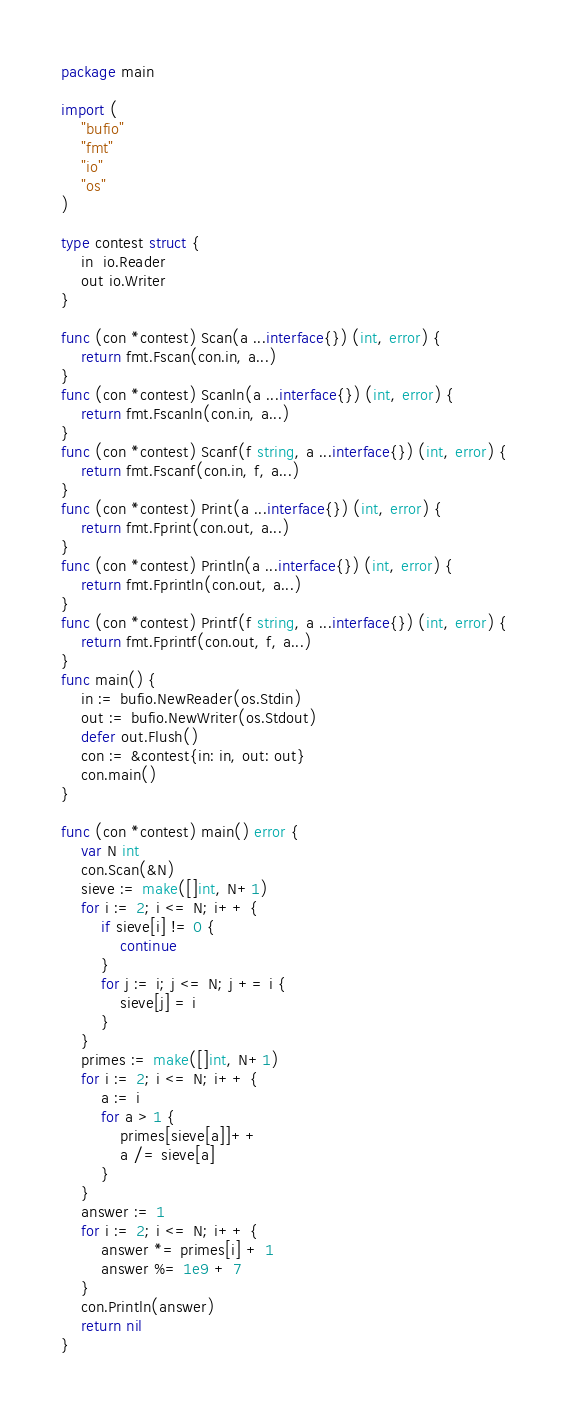<code> <loc_0><loc_0><loc_500><loc_500><_Go_>package main

import (
	"bufio"
	"fmt"
	"io"
	"os"
)

type contest struct {
	in  io.Reader
	out io.Writer
}

func (con *contest) Scan(a ...interface{}) (int, error) {
	return fmt.Fscan(con.in, a...)
}
func (con *contest) Scanln(a ...interface{}) (int, error) {
	return fmt.Fscanln(con.in, a...)
}
func (con *contest) Scanf(f string, a ...interface{}) (int, error) {
	return fmt.Fscanf(con.in, f, a...)
}
func (con *contest) Print(a ...interface{}) (int, error) {
	return fmt.Fprint(con.out, a...)
}
func (con *contest) Println(a ...interface{}) (int, error) {
	return fmt.Fprintln(con.out, a...)
}
func (con *contest) Printf(f string, a ...interface{}) (int, error) {
	return fmt.Fprintf(con.out, f, a...)
}
func main() {
	in := bufio.NewReader(os.Stdin)
	out := bufio.NewWriter(os.Stdout)
	defer out.Flush()
	con := &contest{in: in, out: out}
	con.main()
}

func (con *contest) main() error {
	var N int
	con.Scan(&N)
	sieve := make([]int, N+1)
	for i := 2; i <= N; i++ {
		if sieve[i] != 0 {
			continue
		}
		for j := i; j <= N; j += i {
			sieve[j] = i
		}
	}
	primes := make([]int, N+1)
	for i := 2; i <= N; i++ {
		a := i
		for a > 1 {
			primes[sieve[a]]++
			a /= sieve[a]
		}
	}
	answer := 1
	for i := 2; i <= N; i++ {
		answer *= primes[i] + 1
		answer %= 1e9 + 7
	}
	con.Println(answer)
	return nil
}
</code> 